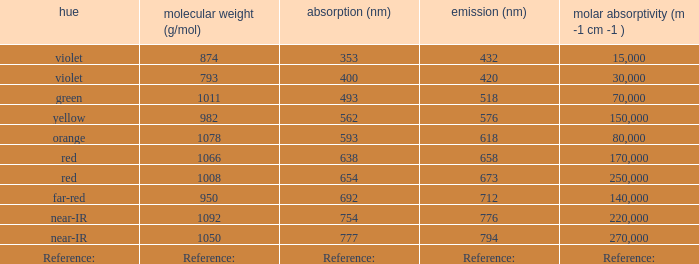Which ε (M -1 cm -1) has a molar mass of 1008 g/mol? 250000.0. 